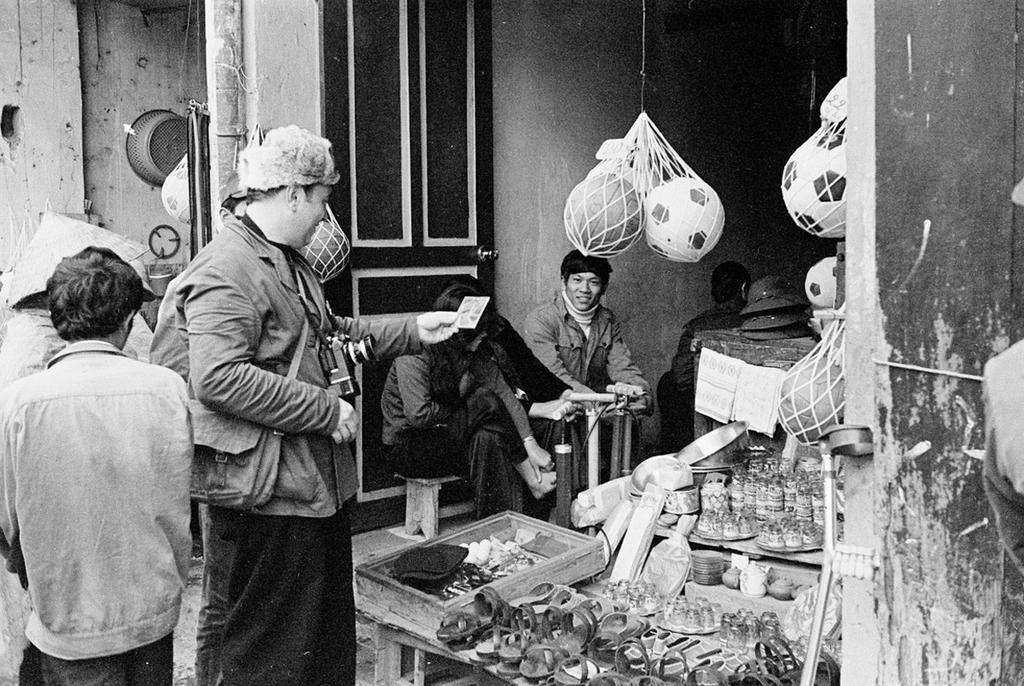Describe this image in one or two sentences. In this image I can see some people. On the right side, I can see some objects on the table. I can see the image is in black and white color. 